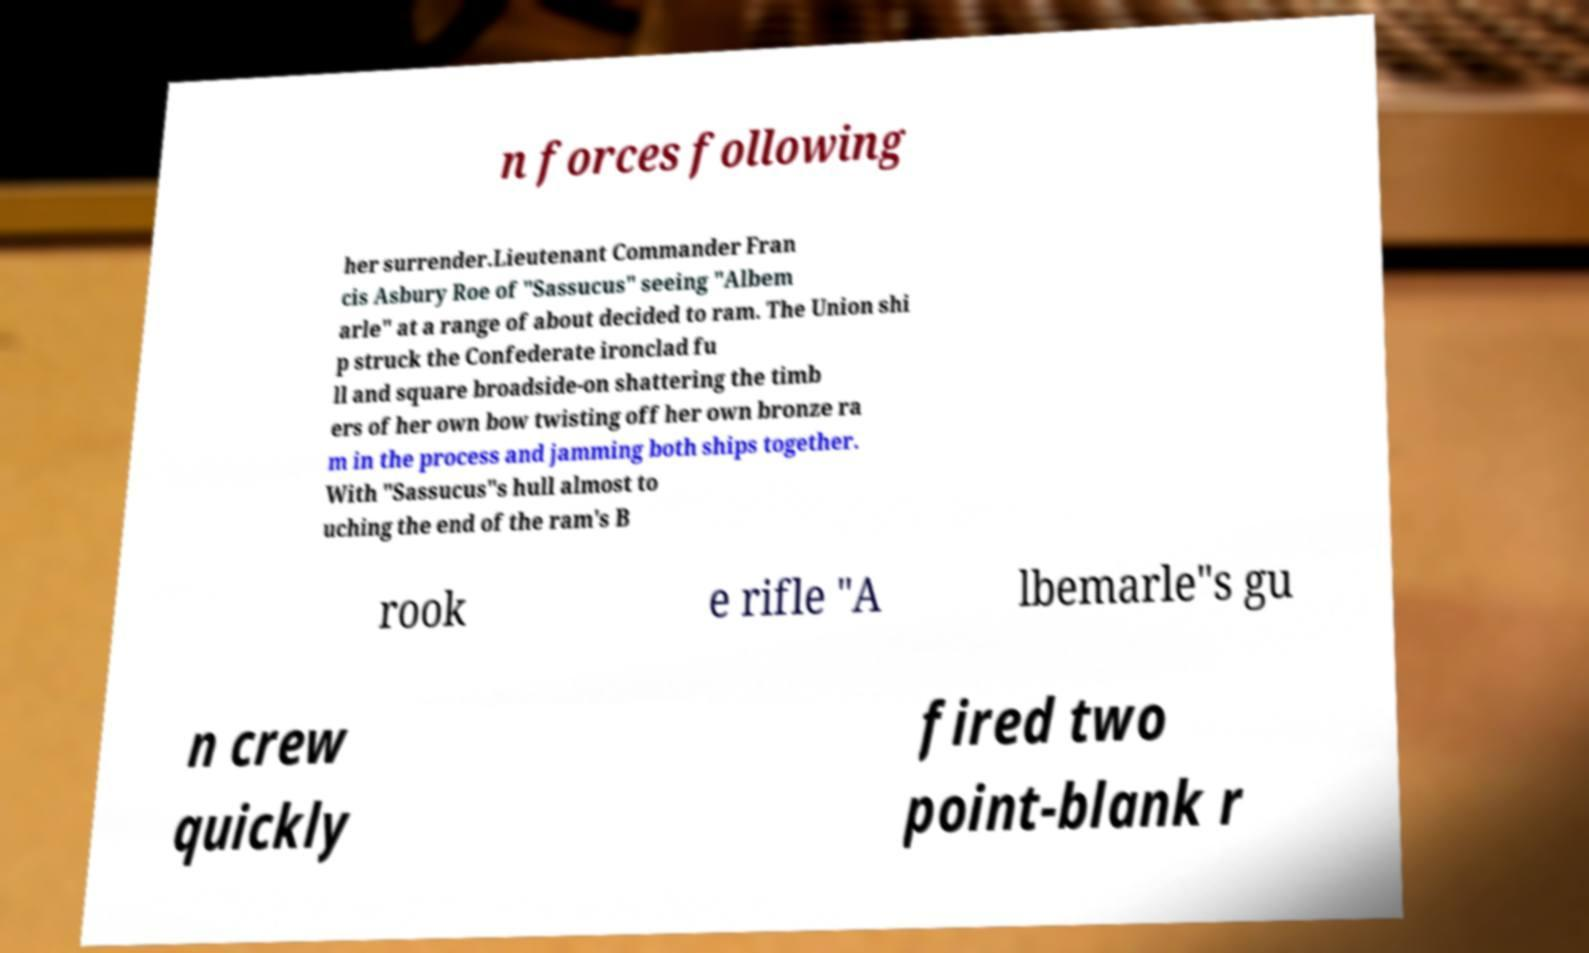There's text embedded in this image that I need extracted. Can you transcribe it verbatim? n forces following her surrender.Lieutenant Commander Fran cis Asbury Roe of "Sassucus" seeing "Albem arle" at a range of about decided to ram. The Union shi p struck the Confederate ironclad fu ll and square broadside-on shattering the timb ers of her own bow twisting off her own bronze ra m in the process and jamming both ships together. With "Sassucus"s hull almost to uching the end of the ram's B rook e rifle "A lbemarle"s gu n crew quickly fired two point-blank r 